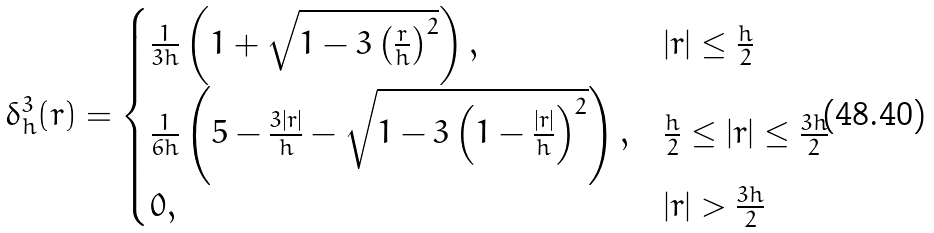<formula> <loc_0><loc_0><loc_500><loc_500>\delta _ { h } ^ { 3 } ( r ) = \begin{cases} \frac { 1 } { 3 h } \left ( 1 + \sqrt { 1 - 3 \left ( \frac { r } { h } \right ) ^ { 2 } } \right ) , & | r | \leq \frac { h } { 2 } \\ \frac { 1 } { 6 h } \left ( 5 - \frac { 3 | r | } { h } - \sqrt { 1 - 3 \left ( 1 - \frac { | r | } { h } \right ) ^ { 2 } } \right ) , & \frac { h } { 2 } \leq | r | \leq \frac { 3 h } { 2 } \\ 0 , & | r | > \frac { 3 h } { 2 } \end{cases}</formula> 